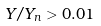Convert formula to latex. <formula><loc_0><loc_0><loc_500><loc_500>Y / Y _ { n } > 0 . 0 1</formula> 